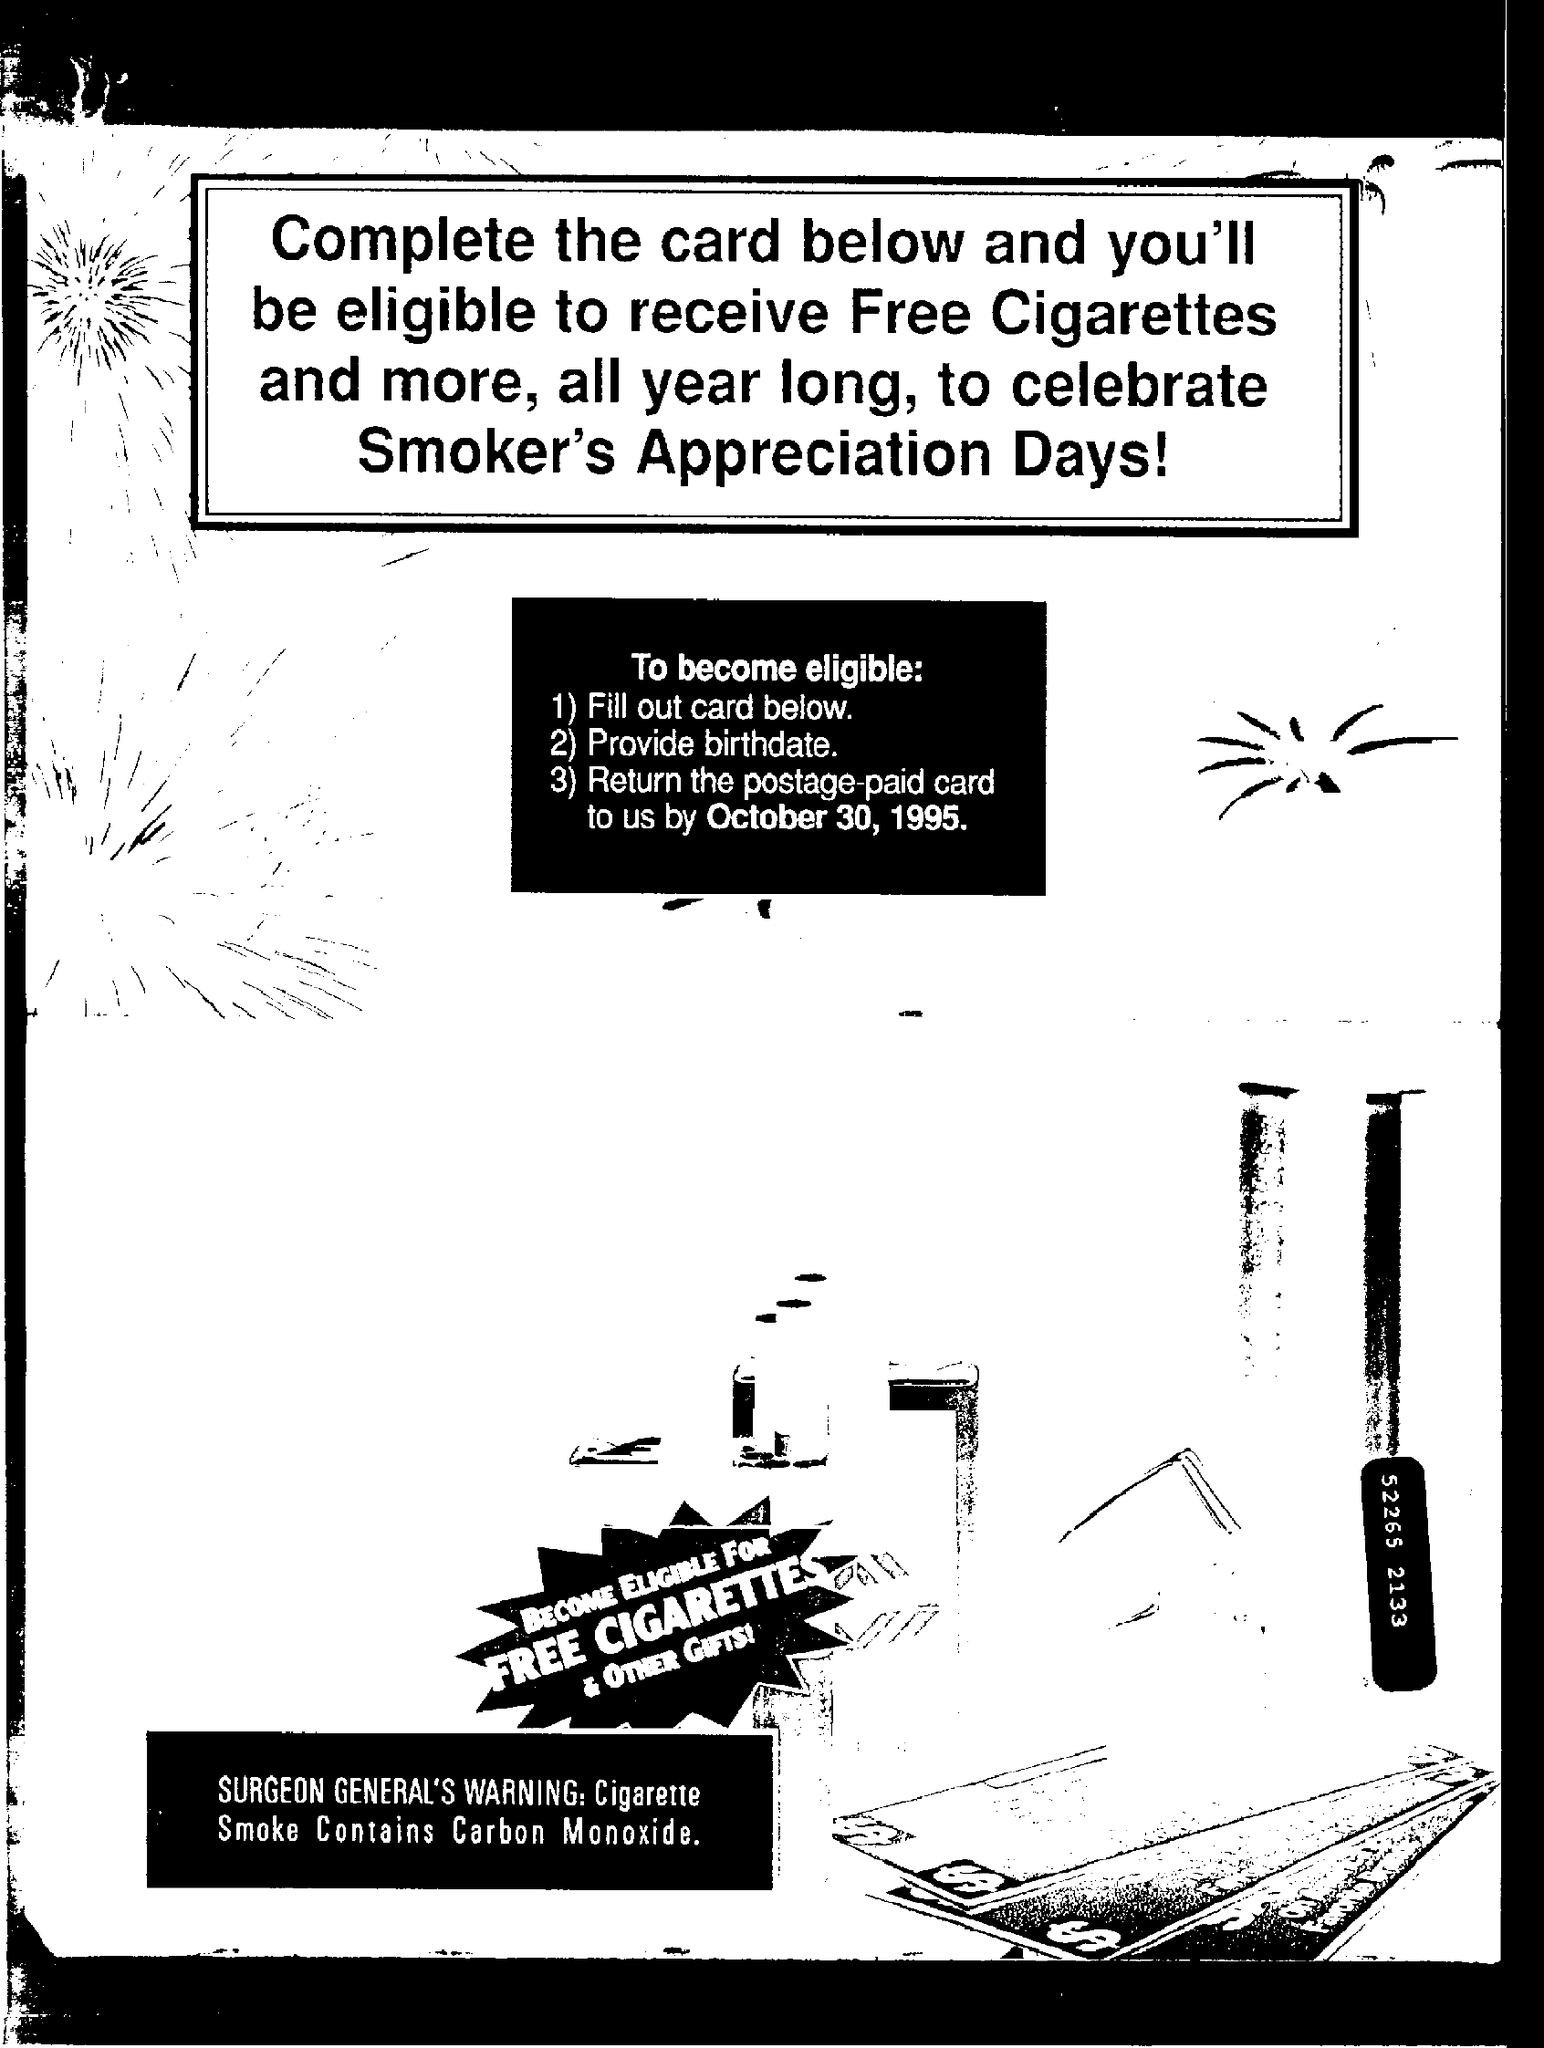Highlight a few significant elements in this photo. Cigarette smoke contains carbon monoxide, a toxic gas that can have negative effects on the health of those who inhale it. 